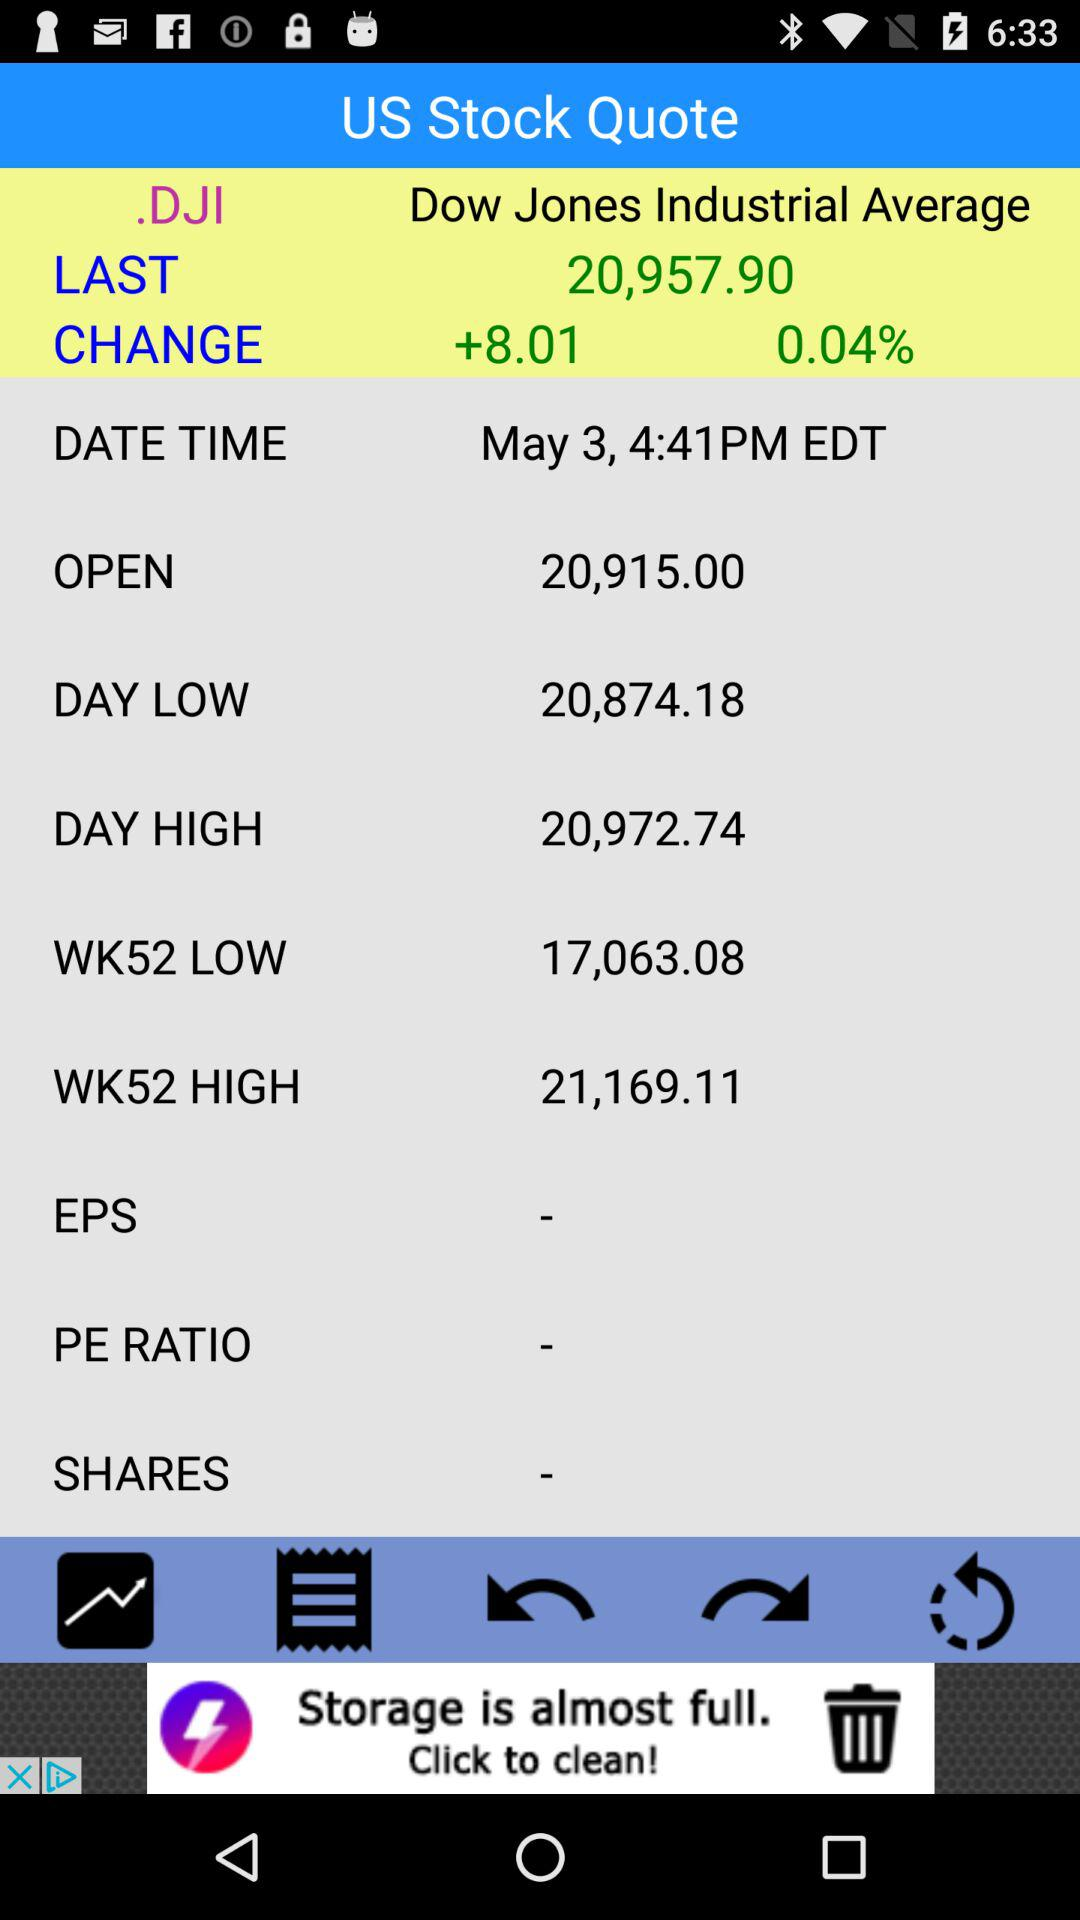What is the date for.DJI stock? The date is May 3. 